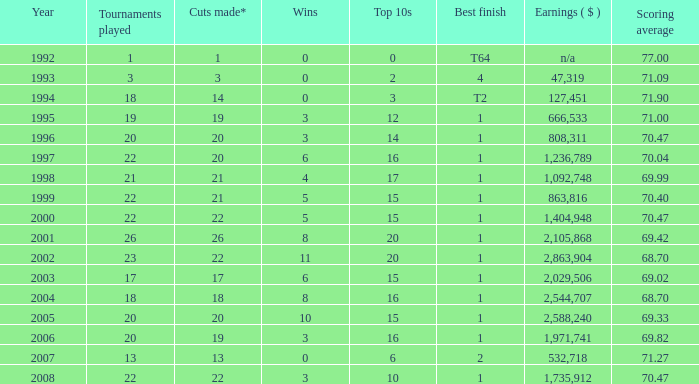Provide the maximum triumphs for years under 2000, optimal ending of 4, and events engaged in less than None. 